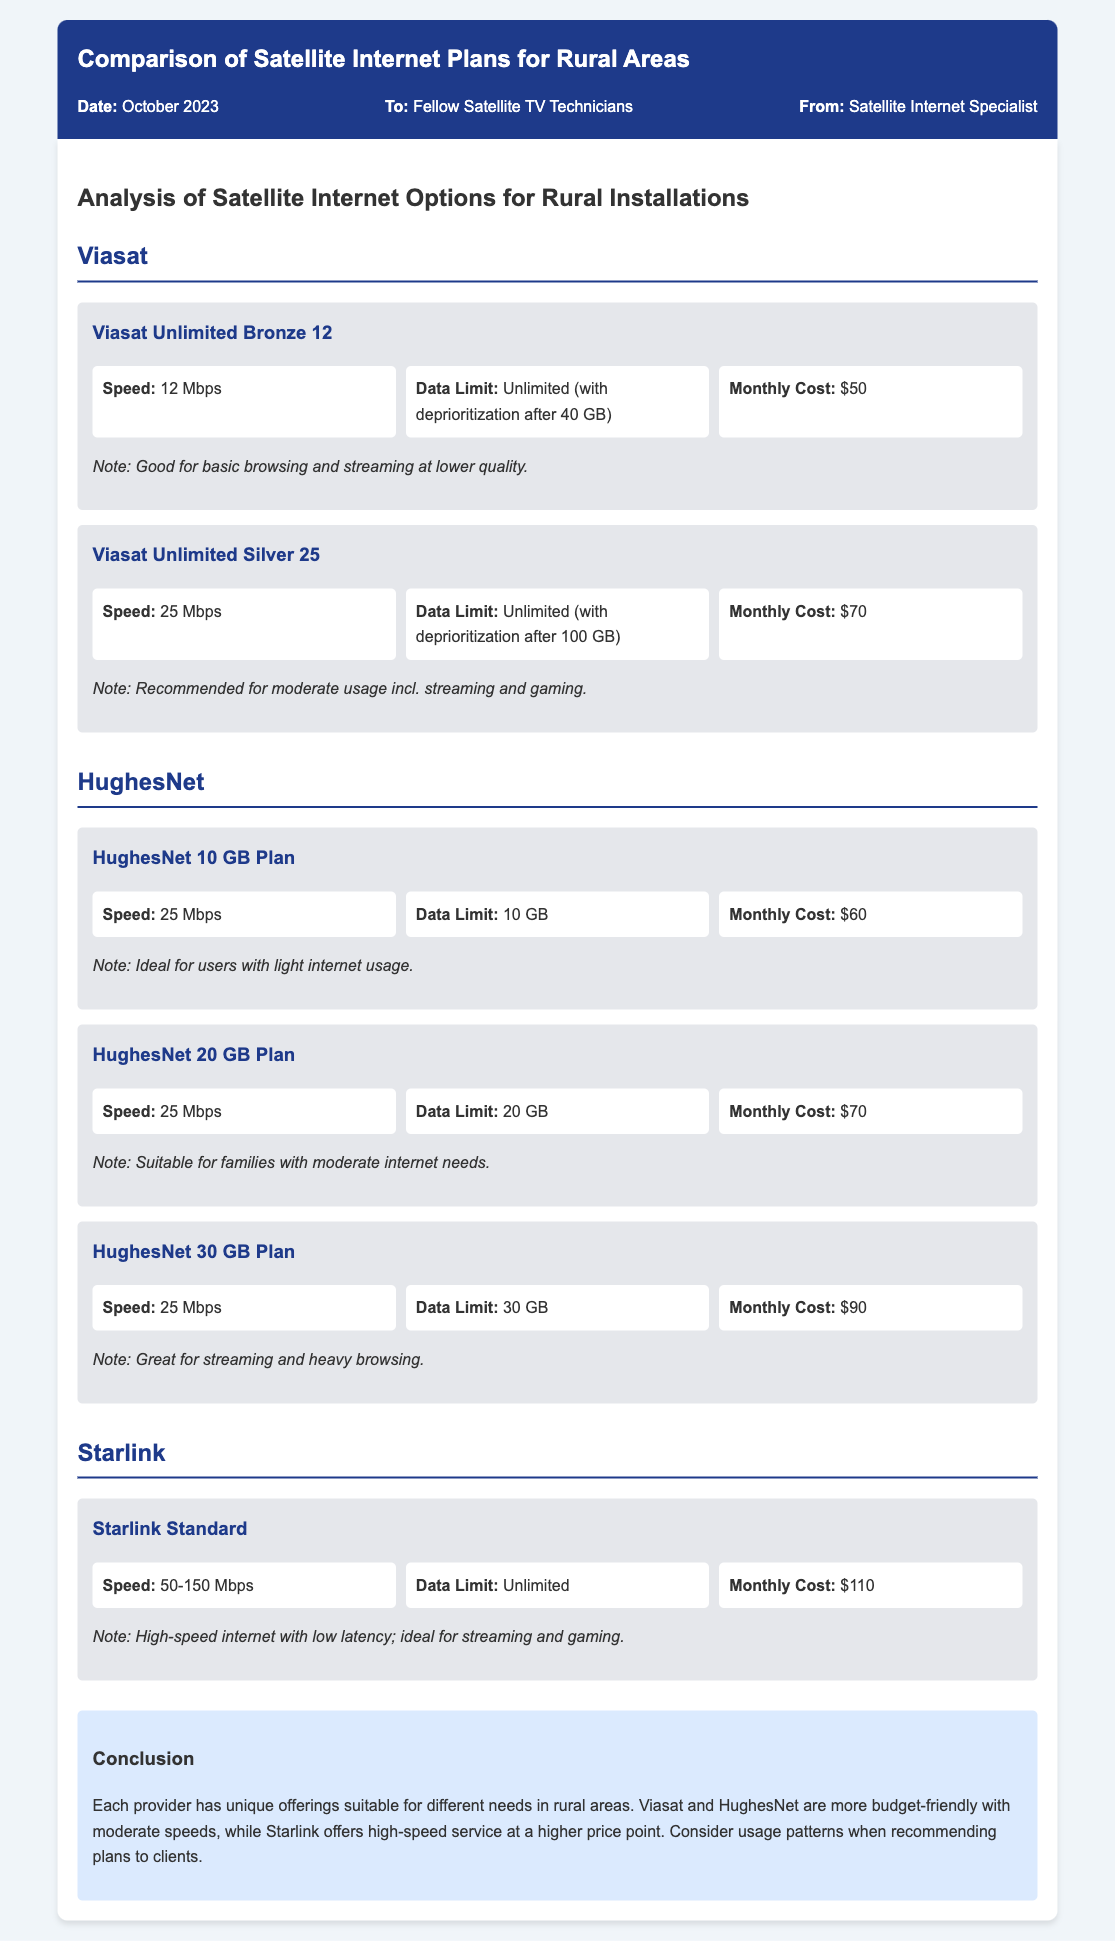What is the speed of the Viasat Unlimited Bronze 12 plan? The speed for this plan is specified in the plan details section under the Viasat provider, which states it is 12 Mbps.
Answer: 12 Mbps What is the data limit for the HughesNet 30 GB Plan? The document outlines the data limit in the plan details section, indicating it is 30 GB.
Answer: 30 GB How much does the Starlink Standard plan cost? The monthly cost for Starlink Standard is provided in the plan details, which states it is $110.
Answer: $110 Which Viasat plan is recommended for moderate usage? The document indicates that the Viasat Unlimited Silver 25 plan is recommended for moderate usage, as noted in its description.
Answer: Viasat Unlimited Silver 25 What is the highest monthly cost among the plans listed? The conclusion and plan sections outline the pricing for each, revealing that Starlink Standard at $110 is the highest cost.
Answer: $110 Which provider offers unlimited data? The data limits section shows that both Starlink and Viasat plans offer unlimited data in different conditions.
Answer: Starlink and Viasat What is the data allowance after deprioritization for Viasat's Unlimited Bronze 12 Plan? The memo specifies the deprioritization condition indicating unlimited data with deprioritization after 40 GB.
Answer: 40 GB Which plan is suited for light internet usage? The document mentions that the HughesNet 10 GB Plan is ideal for users with light internet usage, as noted in its description.
Answer: HughesNet 10 GB Plan 